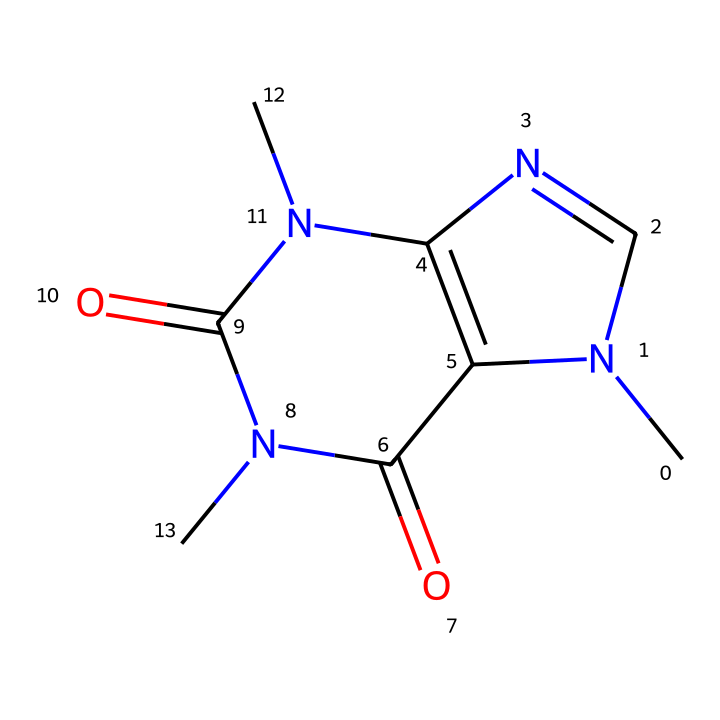What is the molecular formula of caffeine? The SMILES representation reveals the structure consists of carbon (C), nitrogen (N), and oxygen (O) atoms. Counting these gives us C8H10N4O2.
Answer: C8H10N4O2 How many rings are present in the caffeine structure? By analyzing the structure, I can see that caffeine contains two fused ring systems (a bicyclic structure), which counts as one main complex ring.
Answer: 2 What type of bond is most prevalent in the caffeine structure? Looking at the connections within the SMILES, the most prevalent bond type is the single bond, although there are also double bonds shown in the connections.
Answer: single How does caffeine influence programming productivity? Caffeine primarily acts as a central nervous system stimulant, increasing alertness and reducing fatigue, which can enhance focus during programming tasks.
Answer: stimulates What specific alkaloid family does caffeine belong to? The structure is characteristic of methylxanthines, a subclass of alkaloids found in various plants, indicating the family to which caffeine belongs.
Answer: methylxanthines Which atoms in the caffeine molecule contribute to its psychoactive effects? The nitrogen atoms are primarily responsible for the psychoactive properties of caffeine, as they influence the neurotransmitter pathways in the brain.
Answer: nitrogen What is the role of the carbonyl groups in caffeine's activity? The carbonyl groups in the structure enhance the molecule's interactions with receptors, which is essential for its stimulating effects on the nervous system.
Answer: interactions 